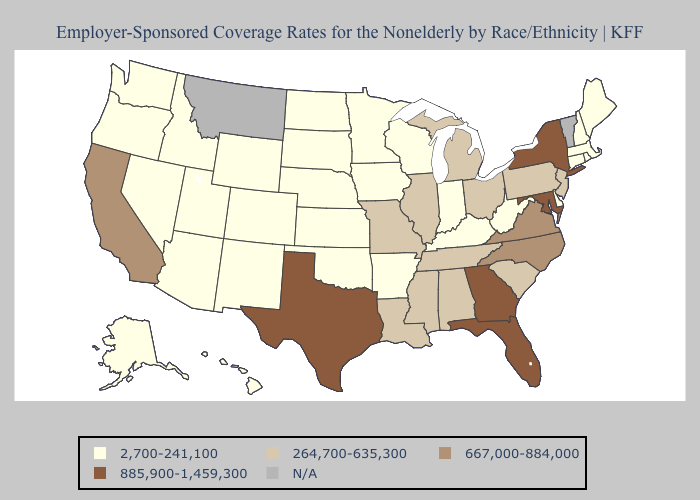Does Indiana have the highest value in the USA?
Be succinct. No. Which states have the lowest value in the West?
Short answer required. Alaska, Arizona, Colorado, Hawaii, Idaho, Nevada, New Mexico, Oregon, Utah, Washington, Wyoming. Among the states that border Missouri , which have the lowest value?
Quick response, please. Arkansas, Iowa, Kansas, Kentucky, Nebraska, Oklahoma. What is the lowest value in the MidWest?
Concise answer only. 2,700-241,100. What is the highest value in the USA?
Be succinct. 885,900-1,459,300. Does the map have missing data?
Be succinct. Yes. What is the value of New Mexico?
Concise answer only. 2,700-241,100. Among the states that border Colorado , which have the lowest value?
Concise answer only. Arizona, Kansas, Nebraska, New Mexico, Oklahoma, Utah, Wyoming. Which states have the lowest value in the West?
Short answer required. Alaska, Arizona, Colorado, Hawaii, Idaho, Nevada, New Mexico, Oregon, Utah, Washington, Wyoming. Does Colorado have the lowest value in the West?
Quick response, please. Yes. Which states have the lowest value in the USA?
Concise answer only. Alaska, Arizona, Arkansas, Colorado, Connecticut, Delaware, Hawaii, Idaho, Indiana, Iowa, Kansas, Kentucky, Maine, Massachusetts, Minnesota, Nebraska, Nevada, New Hampshire, New Mexico, North Dakota, Oklahoma, Oregon, Rhode Island, South Dakota, Utah, Washington, West Virginia, Wisconsin, Wyoming. What is the value of Minnesota?
Short answer required. 2,700-241,100. Which states hav the highest value in the South?
Answer briefly. Florida, Georgia, Maryland, Texas. 